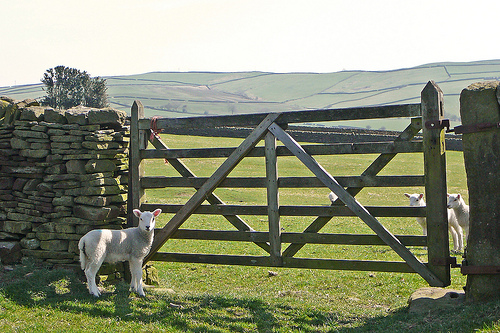What type of landscape surrounds the sheep? The sheep are surrounded by a verdant, rolling landscape typical of rural farmlands. Stone walls, likely made from local stone, crisscross the terrain, which helps in managing livestock and marking property boundaries. 